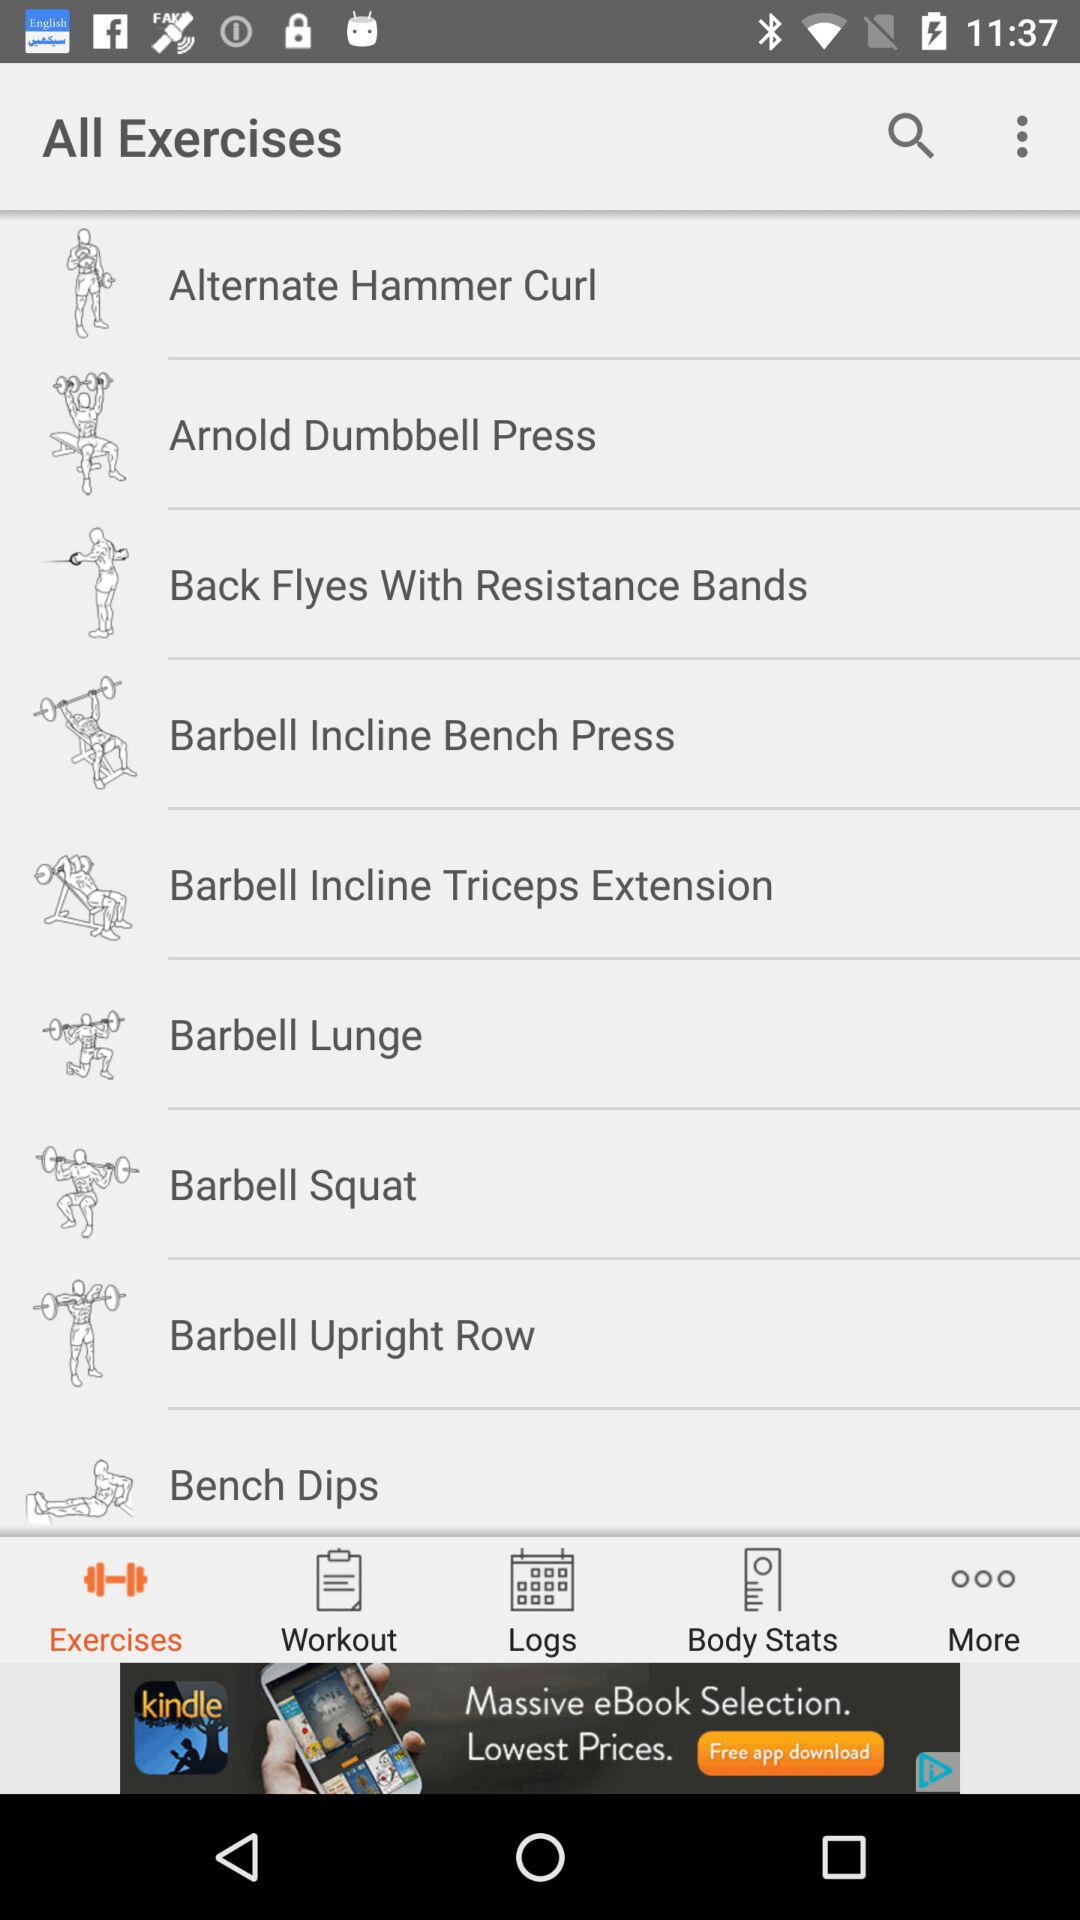Which tab is selected? The selected tab is "Exercises". 